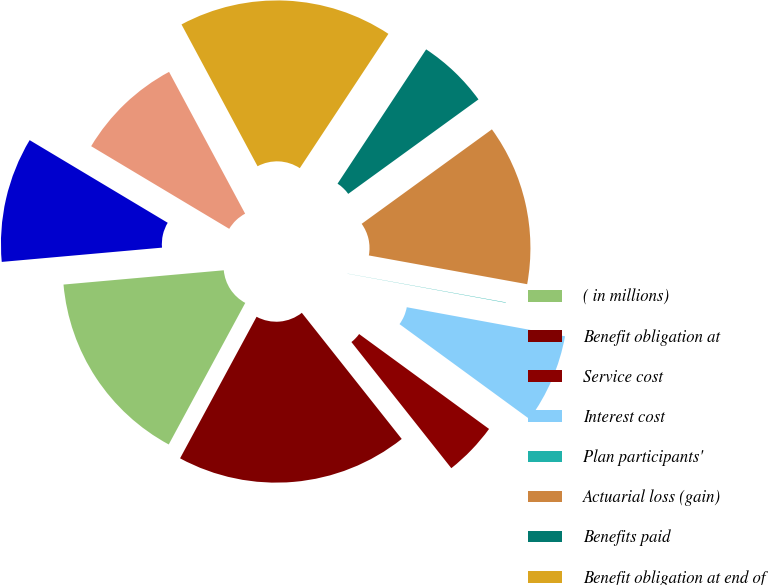<chart> <loc_0><loc_0><loc_500><loc_500><pie_chart><fcel>( in millions)<fcel>Benefit obligation at<fcel>Service cost<fcel>Interest cost<fcel>Plan participants'<fcel>Actuarial loss (gain)<fcel>Benefits paid<fcel>Benefit obligation at end of<fcel>Employer contributions<fcel>Funded status<nl><fcel>15.7%<fcel>18.55%<fcel>4.3%<fcel>7.15%<fcel>0.03%<fcel>12.85%<fcel>5.73%<fcel>17.12%<fcel>8.58%<fcel>10.0%<nl></chart> 